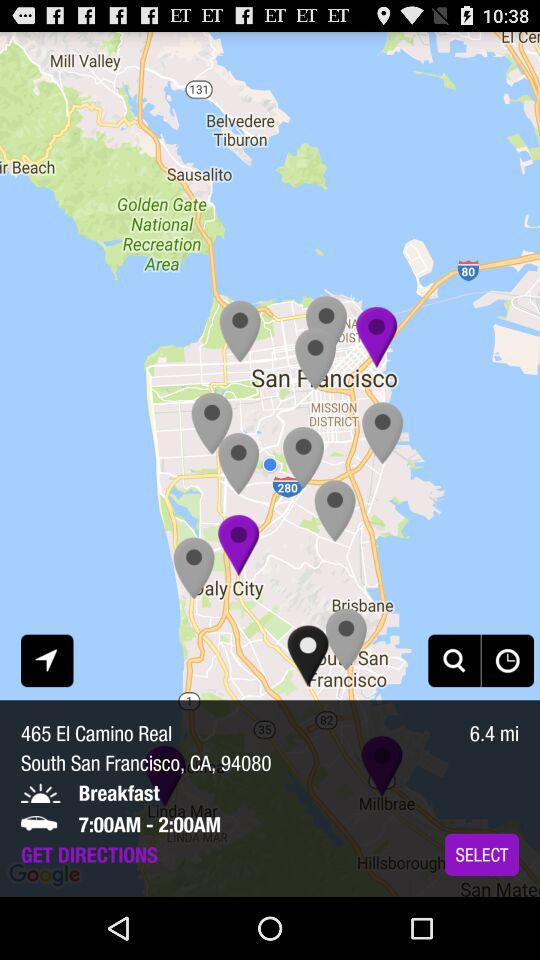What is the given time period? The given time period is 7:00AM-2:00AM. 